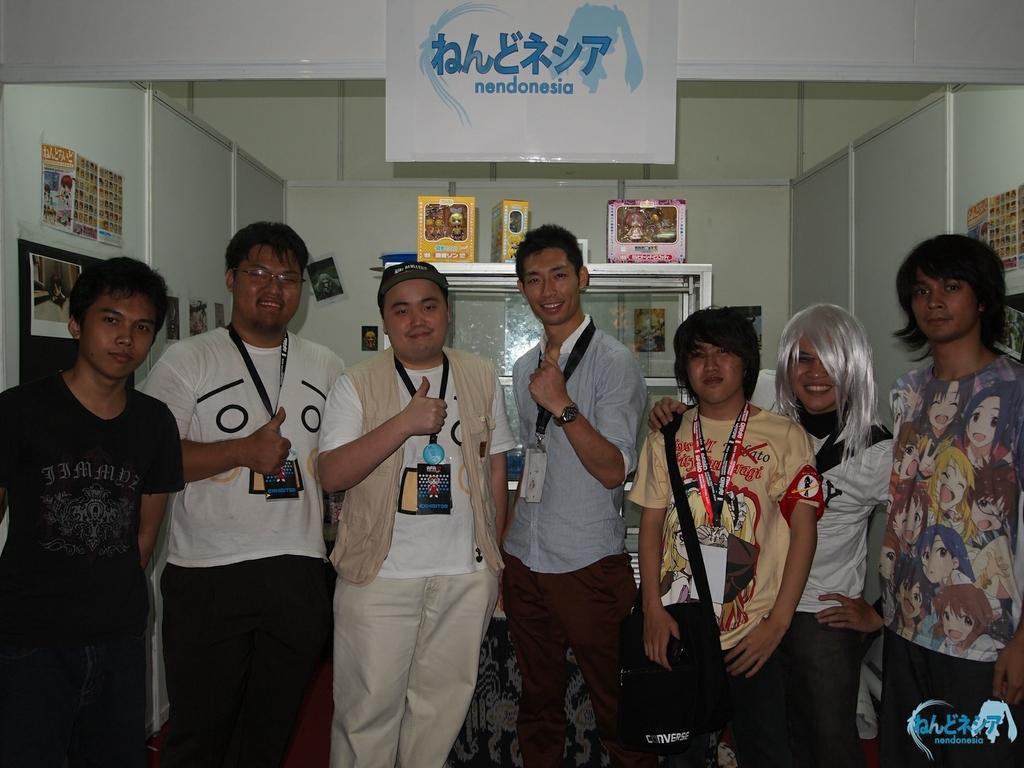In one or two sentences, can you explain what this image depicts? In this image we can see a group of people standing and few people are wearing identity cards. There are few objects placed on the rack. There are few posters and photos on the walls. There is some text at the bottom of the image. 